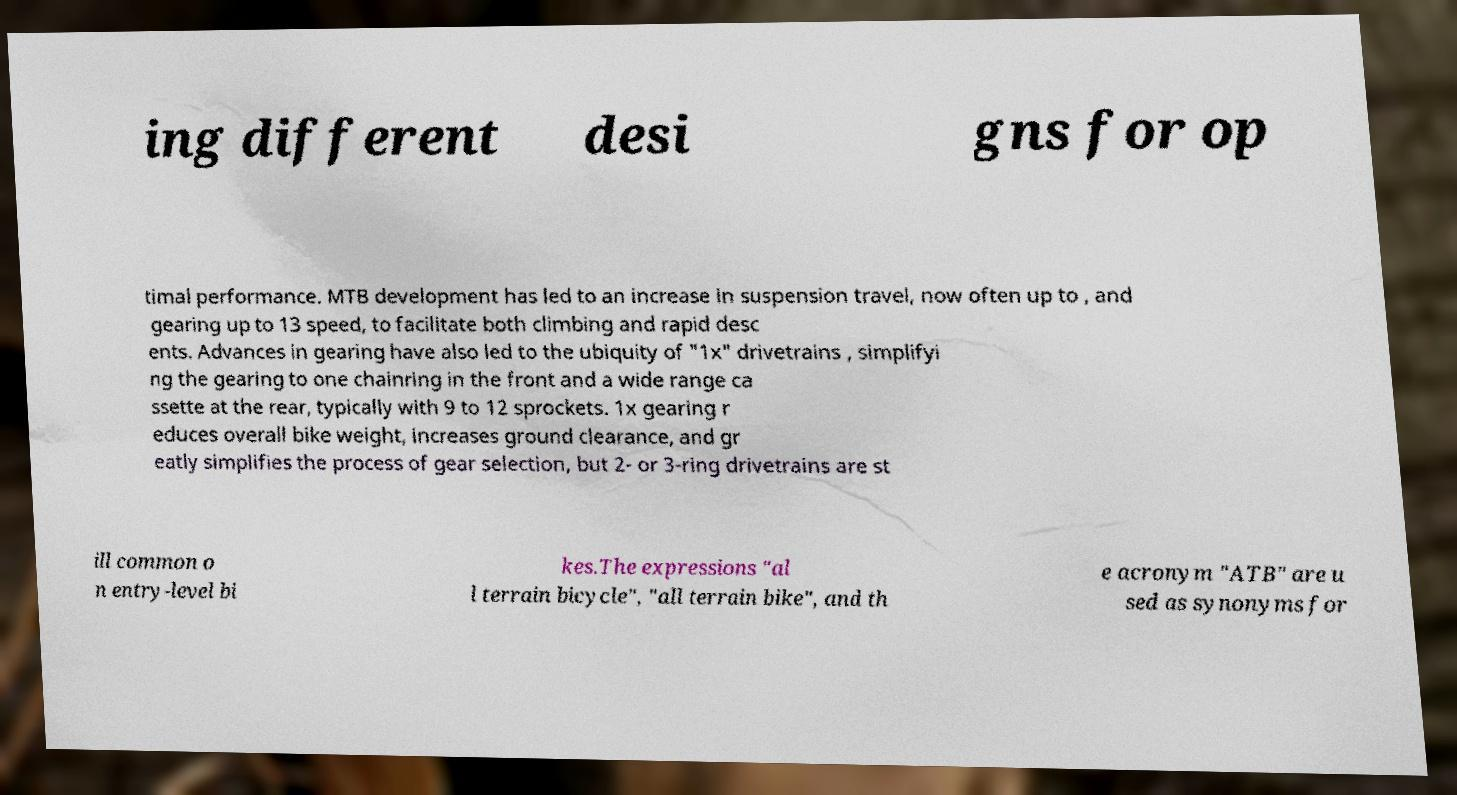Can you accurately transcribe the text from the provided image for me? ing different desi gns for op timal performance. MTB development has led to an increase in suspension travel, now often up to , and gearing up to 13 speed, to facilitate both climbing and rapid desc ents. Advances in gearing have also led to the ubiquity of "1x" drivetrains , simplifyi ng the gearing to one chainring in the front and a wide range ca ssette at the rear, typically with 9 to 12 sprockets. 1x gearing r educes overall bike weight, increases ground clearance, and gr eatly simplifies the process of gear selection, but 2- or 3-ring drivetrains are st ill common o n entry-level bi kes.The expressions "al l terrain bicycle", "all terrain bike", and th e acronym "ATB" are u sed as synonyms for 